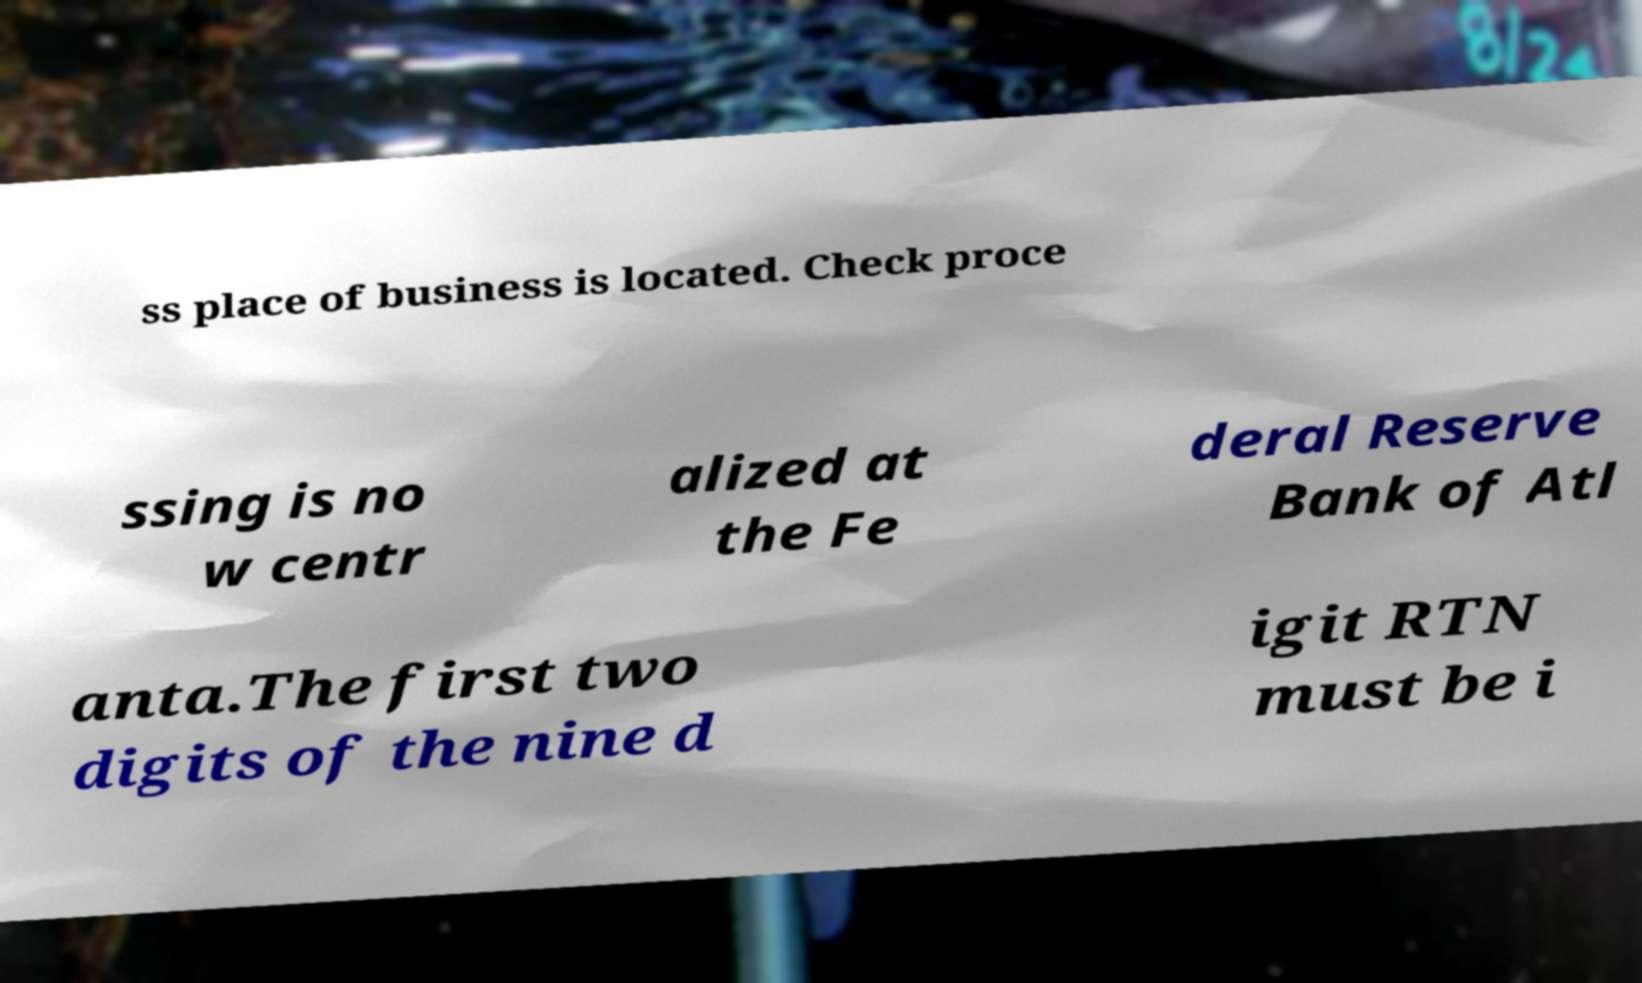Can you accurately transcribe the text from the provided image for me? ss place of business is located. Check proce ssing is no w centr alized at the Fe deral Reserve Bank of Atl anta.The first two digits of the nine d igit RTN must be i 